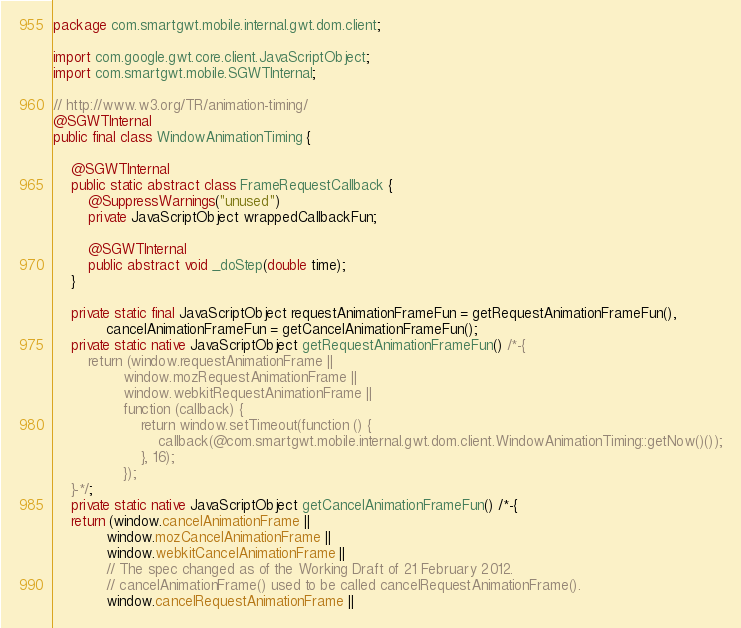<code> <loc_0><loc_0><loc_500><loc_500><_Java_>package com.smartgwt.mobile.internal.gwt.dom.client;

import com.google.gwt.core.client.JavaScriptObject;
import com.smartgwt.mobile.SGWTInternal;

// http://www.w3.org/TR/animation-timing/
@SGWTInternal
public final class WindowAnimationTiming {

    @SGWTInternal
    public static abstract class FrameRequestCallback {
        @SuppressWarnings("unused")
        private JavaScriptObject wrappedCallbackFun;

        @SGWTInternal
        public abstract void _doStep(double time);
    }

    private static final JavaScriptObject requestAnimationFrameFun = getRequestAnimationFrameFun(),
            cancelAnimationFrameFun = getCancelAnimationFrameFun();
    private static native JavaScriptObject getRequestAnimationFrameFun() /*-{
        return (window.requestAnimationFrame ||
                window.mozRequestAnimationFrame ||
                window.webkitRequestAnimationFrame ||
                function (callback) {
                    return window.setTimeout(function () {
                        callback(@com.smartgwt.mobile.internal.gwt.dom.client.WindowAnimationTiming::getNow()());
                    }, 16);
                });
    }-*/;
    private static native JavaScriptObject getCancelAnimationFrameFun() /*-{
    return (window.cancelAnimationFrame ||
            window.mozCancelAnimationFrame ||
            window.webkitCancelAnimationFrame ||
            // The spec changed as of the Working Draft of 21 February 2012.
            // cancelAnimationFrame() used to be called cancelRequestAnimationFrame().
            window.cancelRequestAnimationFrame ||</code> 